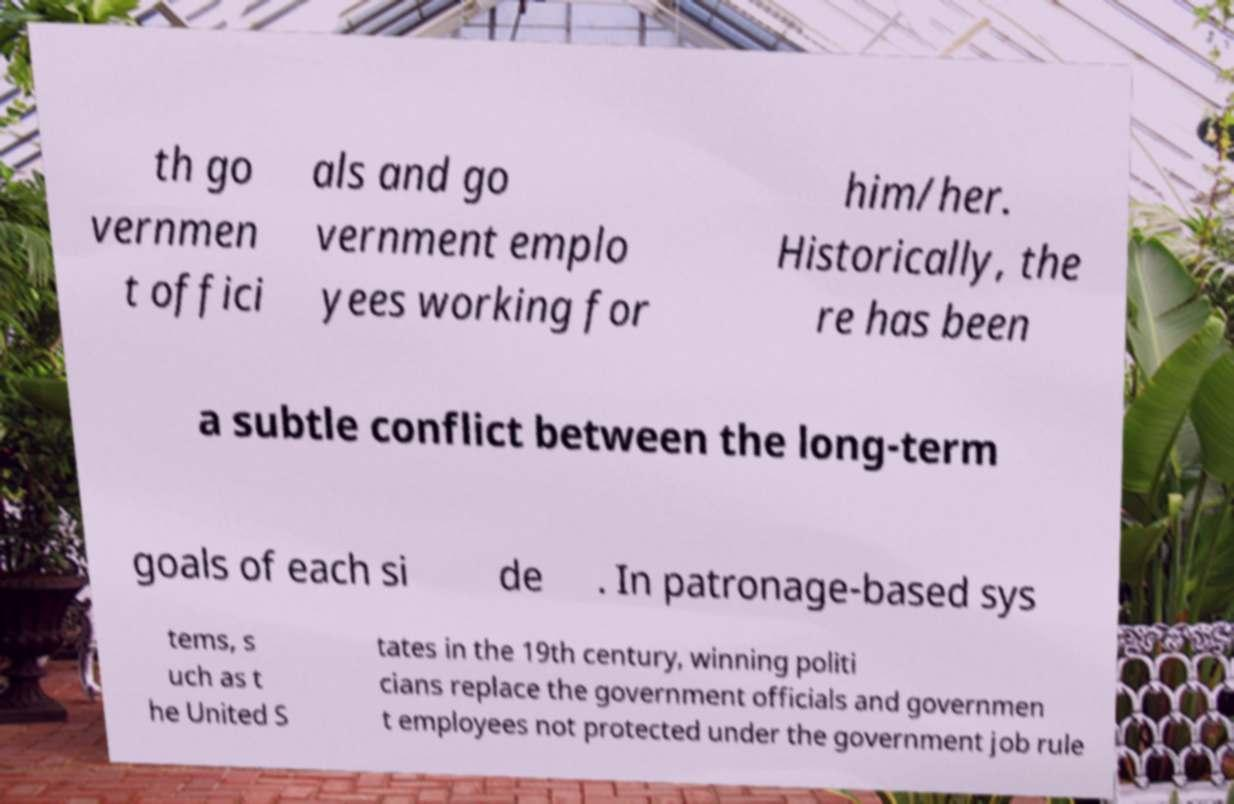Please read and relay the text visible in this image. What does it say? th go vernmen t offici als and go vernment emplo yees working for him/her. Historically, the re has been a subtle conflict between the long-term goals of each si de . In patronage-based sys tems, s uch as t he United S tates in the 19th century, winning politi cians replace the government officials and governmen t employees not protected under the government job rule 